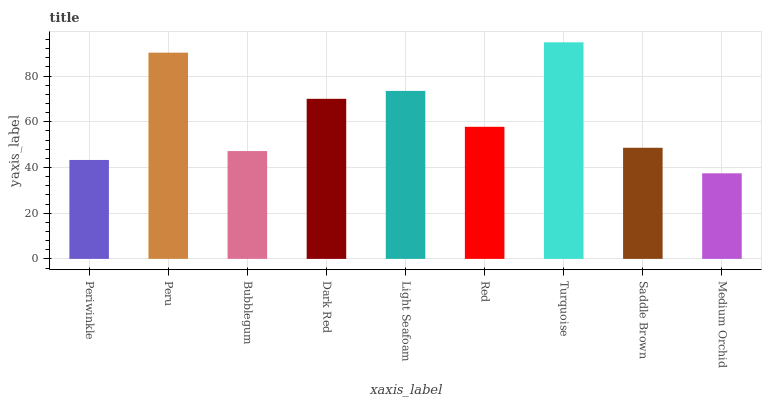Is Medium Orchid the minimum?
Answer yes or no. Yes. Is Turquoise the maximum?
Answer yes or no. Yes. Is Peru the minimum?
Answer yes or no. No. Is Peru the maximum?
Answer yes or no. No. Is Peru greater than Periwinkle?
Answer yes or no. Yes. Is Periwinkle less than Peru?
Answer yes or no. Yes. Is Periwinkle greater than Peru?
Answer yes or no. No. Is Peru less than Periwinkle?
Answer yes or no. No. Is Red the high median?
Answer yes or no. Yes. Is Red the low median?
Answer yes or no. Yes. Is Saddle Brown the high median?
Answer yes or no. No. Is Light Seafoam the low median?
Answer yes or no. No. 